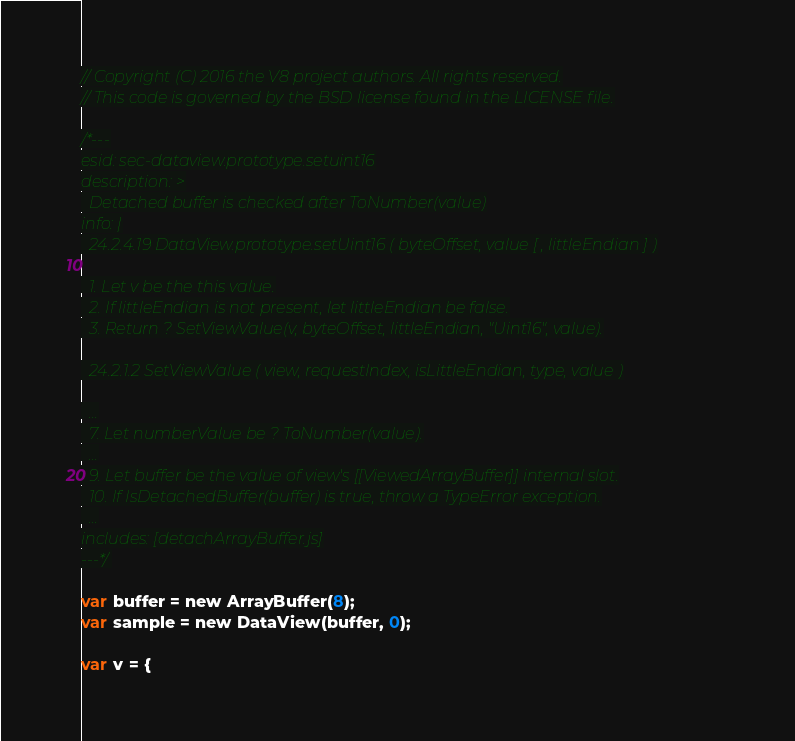<code> <loc_0><loc_0><loc_500><loc_500><_JavaScript_>// Copyright (C) 2016 the V8 project authors. All rights reserved.
// This code is governed by the BSD license found in the LICENSE file.

/*---
esid: sec-dataview.prototype.setuint16
description: >
  Detached buffer is checked after ToNumber(value)
info: |
  24.2.4.19 DataView.prototype.setUint16 ( byteOffset, value [ , littleEndian ] )

  1. Let v be the this value.
  2. If littleEndian is not present, let littleEndian be false.
  3. Return ? SetViewValue(v, byteOffset, littleEndian, "Uint16", value).

  24.2.1.2 SetViewValue ( view, requestIndex, isLittleEndian, type, value )

  ...
  7. Let numberValue be ? ToNumber(value).
  ...
  9. Let buffer be the value of view's [[ViewedArrayBuffer]] internal slot.
  10. If IsDetachedBuffer(buffer) is true, throw a TypeError exception.
  ...
includes: [detachArrayBuffer.js]
---*/

var buffer = new ArrayBuffer(8);
var sample = new DataView(buffer, 0);

var v = {</code> 